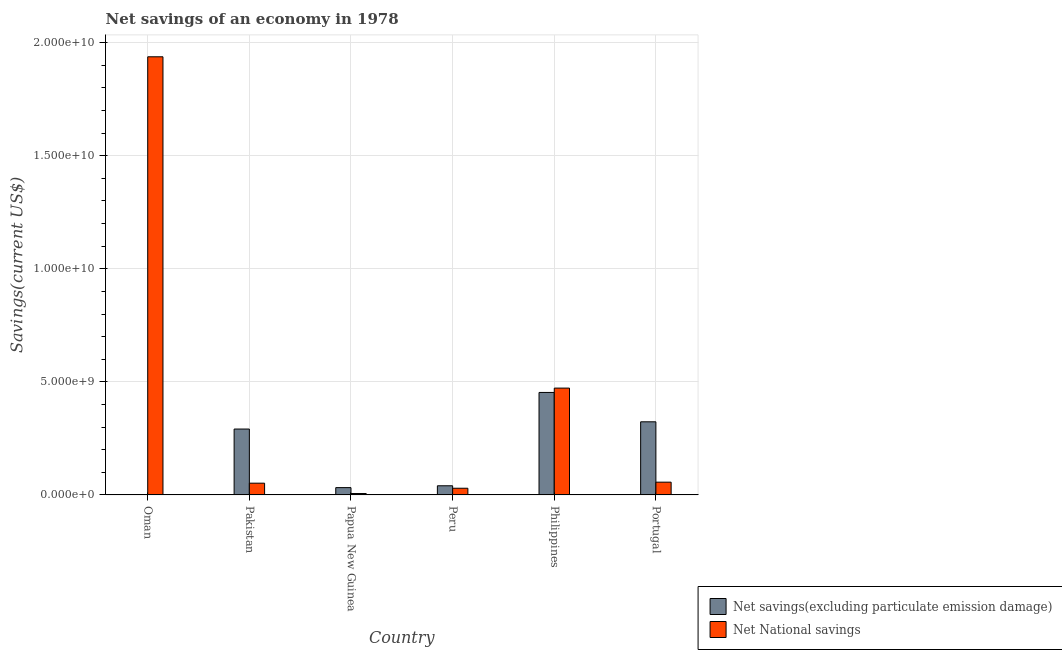Are the number of bars per tick equal to the number of legend labels?
Ensure brevity in your answer.  No. Are the number of bars on each tick of the X-axis equal?
Give a very brief answer. No. In how many cases, is the number of bars for a given country not equal to the number of legend labels?
Ensure brevity in your answer.  1. What is the net savings(excluding particulate emission damage) in Papua New Guinea?
Make the answer very short. 3.23e+08. Across all countries, what is the maximum net national savings?
Keep it short and to the point. 1.94e+1. In which country was the net savings(excluding particulate emission damage) maximum?
Make the answer very short. Philippines. What is the total net savings(excluding particulate emission damage) in the graph?
Keep it short and to the point. 1.14e+1. What is the difference between the net savings(excluding particulate emission damage) in Pakistan and that in Portugal?
Your answer should be compact. -3.20e+08. What is the difference between the net national savings in Peru and the net savings(excluding particulate emission damage) in Papua New Guinea?
Your answer should be compact. -2.77e+07. What is the average net savings(excluding particulate emission damage) per country?
Make the answer very short. 1.90e+09. What is the difference between the net national savings and net savings(excluding particulate emission damage) in Pakistan?
Give a very brief answer. -2.39e+09. In how many countries, is the net savings(excluding particulate emission damage) greater than 3000000000 US$?
Make the answer very short. 2. What is the ratio of the net savings(excluding particulate emission damage) in Pakistan to that in Peru?
Provide a succinct answer. 7.2. What is the difference between the highest and the second highest net national savings?
Keep it short and to the point. 1.47e+1. What is the difference between the highest and the lowest net national savings?
Your answer should be very brief. 1.93e+1. In how many countries, is the net national savings greater than the average net national savings taken over all countries?
Make the answer very short. 2. Is the sum of the net national savings in Oman and Pakistan greater than the maximum net savings(excluding particulate emission damage) across all countries?
Ensure brevity in your answer.  Yes. Are all the bars in the graph horizontal?
Ensure brevity in your answer.  No. How many countries are there in the graph?
Your response must be concise. 6. Are the values on the major ticks of Y-axis written in scientific E-notation?
Give a very brief answer. Yes. Does the graph contain grids?
Your response must be concise. Yes. Where does the legend appear in the graph?
Offer a terse response. Bottom right. What is the title of the graph?
Your answer should be compact. Net savings of an economy in 1978. What is the label or title of the X-axis?
Offer a very short reply. Country. What is the label or title of the Y-axis?
Ensure brevity in your answer.  Savings(current US$). What is the Savings(current US$) in Net savings(excluding particulate emission damage) in Oman?
Ensure brevity in your answer.  0. What is the Savings(current US$) in Net National savings in Oman?
Keep it short and to the point. 1.94e+1. What is the Savings(current US$) of Net savings(excluding particulate emission damage) in Pakistan?
Make the answer very short. 2.91e+09. What is the Savings(current US$) of Net National savings in Pakistan?
Provide a succinct answer. 5.20e+08. What is the Savings(current US$) in Net savings(excluding particulate emission damage) in Papua New Guinea?
Give a very brief answer. 3.23e+08. What is the Savings(current US$) of Net National savings in Papua New Guinea?
Provide a short and direct response. 6.22e+07. What is the Savings(current US$) in Net savings(excluding particulate emission damage) in Peru?
Your answer should be compact. 4.05e+08. What is the Savings(current US$) in Net National savings in Peru?
Keep it short and to the point. 2.96e+08. What is the Savings(current US$) in Net savings(excluding particulate emission damage) in Philippines?
Provide a short and direct response. 4.53e+09. What is the Savings(current US$) in Net National savings in Philippines?
Provide a succinct answer. 4.72e+09. What is the Savings(current US$) of Net savings(excluding particulate emission damage) in Portugal?
Ensure brevity in your answer.  3.23e+09. What is the Savings(current US$) of Net National savings in Portugal?
Give a very brief answer. 5.64e+08. Across all countries, what is the maximum Savings(current US$) in Net savings(excluding particulate emission damage)?
Offer a very short reply. 4.53e+09. Across all countries, what is the maximum Savings(current US$) of Net National savings?
Offer a terse response. 1.94e+1. Across all countries, what is the minimum Savings(current US$) of Net savings(excluding particulate emission damage)?
Offer a terse response. 0. Across all countries, what is the minimum Savings(current US$) in Net National savings?
Ensure brevity in your answer.  6.22e+07. What is the total Savings(current US$) of Net savings(excluding particulate emission damage) in the graph?
Ensure brevity in your answer.  1.14e+1. What is the total Savings(current US$) in Net National savings in the graph?
Provide a succinct answer. 2.55e+1. What is the difference between the Savings(current US$) of Net National savings in Oman and that in Pakistan?
Make the answer very short. 1.89e+1. What is the difference between the Savings(current US$) in Net National savings in Oman and that in Papua New Guinea?
Offer a very short reply. 1.93e+1. What is the difference between the Savings(current US$) of Net National savings in Oman and that in Peru?
Provide a succinct answer. 1.91e+1. What is the difference between the Savings(current US$) in Net National savings in Oman and that in Philippines?
Offer a terse response. 1.47e+1. What is the difference between the Savings(current US$) in Net National savings in Oman and that in Portugal?
Provide a succinct answer. 1.88e+1. What is the difference between the Savings(current US$) of Net savings(excluding particulate emission damage) in Pakistan and that in Papua New Guinea?
Offer a terse response. 2.59e+09. What is the difference between the Savings(current US$) of Net National savings in Pakistan and that in Papua New Guinea?
Your response must be concise. 4.58e+08. What is the difference between the Savings(current US$) of Net savings(excluding particulate emission damage) in Pakistan and that in Peru?
Make the answer very short. 2.51e+09. What is the difference between the Savings(current US$) in Net National savings in Pakistan and that in Peru?
Give a very brief answer. 2.24e+08. What is the difference between the Savings(current US$) of Net savings(excluding particulate emission damage) in Pakistan and that in Philippines?
Ensure brevity in your answer.  -1.62e+09. What is the difference between the Savings(current US$) in Net National savings in Pakistan and that in Philippines?
Your answer should be compact. -4.20e+09. What is the difference between the Savings(current US$) of Net savings(excluding particulate emission damage) in Pakistan and that in Portugal?
Make the answer very short. -3.20e+08. What is the difference between the Savings(current US$) in Net National savings in Pakistan and that in Portugal?
Keep it short and to the point. -4.46e+07. What is the difference between the Savings(current US$) of Net savings(excluding particulate emission damage) in Papua New Guinea and that in Peru?
Provide a short and direct response. -8.15e+07. What is the difference between the Savings(current US$) of Net National savings in Papua New Guinea and that in Peru?
Offer a terse response. -2.33e+08. What is the difference between the Savings(current US$) of Net savings(excluding particulate emission damage) in Papua New Guinea and that in Philippines?
Make the answer very short. -4.21e+09. What is the difference between the Savings(current US$) in Net National savings in Papua New Guinea and that in Philippines?
Offer a very short reply. -4.66e+09. What is the difference between the Savings(current US$) of Net savings(excluding particulate emission damage) in Papua New Guinea and that in Portugal?
Ensure brevity in your answer.  -2.91e+09. What is the difference between the Savings(current US$) in Net National savings in Papua New Guinea and that in Portugal?
Provide a succinct answer. -5.02e+08. What is the difference between the Savings(current US$) in Net savings(excluding particulate emission damage) in Peru and that in Philippines?
Your answer should be compact. -4.13e+09. What is the difference between the Savings(current US$) in Net National savings in Peru and that in Philippines?
Your answer should be very brief. -4.43e+09. What is the difference between the Savings(current US$) in Net savings(excluding particulate emission damage) in Peru and that in Portugal?
Offer a terse response. -2.83e+09. What is the difference between the Savings(current US$) of Net National savings in Peru and that in Portugal?
Keep it short and to the point. -2.69e+08. What is the difference between the Savings(current US$) in Net savings(excluding particulate emission damage) in Philippines and that in Portugal?
Provide a short and direct response. 1.30e+09. What is the difference between the Savings(current US$) in Net National savings in Philippines and that in Portugal?
Your response must be concise. 4.16e+09. What is the difference between the Savings(current US$) in Net savings(excluding particulate emission damage) in Pakistan and the Savings(current US$) in Net National savings in Papua New Guinea?
Provide a short and direct response. 2.85e+09. What is the difference between the Savings(current US$) of Net savings(excluding particulate emission damage) in Pakistan and the Savings(current US$) of Net National savings in Peru?
Your answer should be very brief. 2.62e+09. What is the difference between the Savings(current US$) of Net savings(excluding particulate emission damage) in Pakistan and the Savings(current US$) of Net National savings in Philippines?
Ensure brevity in your answer.  -1.81e+09. What is the difference between the Savings(current US$) of Net savings(excluding particulate emission damage) in Pakistan and the Savings(current US$) of Net National savings in Portugal?
Offer a very short reply. 2.35e+09. What is the difference between the Savings(current US$) in Net savings(excluding particulate emission damage) in Papua New Guinea and the Savings(current US$) in Net National savings in Peru?
Your response must be concise. 2.77e+07. What is the difference between the Savings(current US$) in Net savings(excluding particulate emission damage) in Papua New Guinea and the Savings(current US$) in Net National savings in Philippines?
Provide a short and direct response. -4.40e+09. What is the difference between the Savings(current US$) in Net savings(excluding particulate emission damage) in Papua New Guinea and the Savings(current US$) in Net National savings in Portugal?
Keep it short and to the point. -2.41e+08. What is the difference between the Savings(current US$) in Net savings(excluding particulate emission damage) in Peru and the Savings(current US$) in Net National savings in Philippines?
Ensure brevity in your answer.  -4.32e+09. What is the difference between the Savings(current US$) in Net savings(excluding particulate emission damage) in Peru and the Savings(current US$) in Net National savings in Portugal?
Provide a short and direct response. -1.60e+08. What is the difference between the Savings(current US$) in Net savings(excluding particulate emission damage) in Philippines and the Savings(current US$) in Net National savings in Portugal?
Provide a short and direct response. 3.97e+09. What is the average Savings(current US$) of Net savings(excluding particulate emission damage) per country?
Provide a short and direct response. 1.90e+09. What is the average Savings(current US$) of Net National savings per country?
Offer a terse response. 4.26e+09. What is the difference between the Savings(current US$) of Net savings(excluding particulate emission damage) and Savings(current US$) of Net National savings in Pakistan?
Offer a terse response. 2.39e+09. What is the difference between the Savings(current US$) in Net savings(excluding particulate emission damage) and Savings(current US$) in Net National savings in Papua New Guinea?
Your answer should be very brief. 2.61e+08. What is the difference between the Savings(current US$) in Net savings(excluding particulate emission damage) and Savings(current US$) in Net National savings in Peru?
Provide a succinct answer. 1.09e+08. What is the difference between the Savings(current US$) of Net savings(excluding particulate emission damage) and Savings(current US$) of Net National savings in Philippines?
Provide a short and direct response. -1.92e+08. What is the difference between the Savings(current US$) of Net savings(excluding particulate emission damage) and Savings(current US$) of Net National savings in Portugal?
Offer a terse response. 2.67e+09. What is the ratio of the Savings(current US$) of Net National savings in Oman to that in Pakistan?
Provide a succinct answer. 37.28. What is the ratio of the Savings(current US$) of Net National savings in Oman to that in Papua New Guinea?
Keep it short and to the point. 311.7. What is the ratio of the Savings(current US$) of Net National savings in Oman to that in Peru?
Provide a short and direct response. 65.55. What is the ratio of the Savings(current US$) in Net National savings in Oman to that in Philippines?
Make the answer very short. 4.1. What is the ratio of the Savings(current US$) of Net National savings in Oman to that in Portugal?
Provide a short and direct response. 34.33. What is the ratio of the Savings(current US$) of Net savings(excluding particulate emission damage) in Pakistan to that in Papua New Guinea?
Your response must be concise. 9.01. What is the ratio of the Savings(current US$) of Net National savings in Pakistan to that in Papua New Guinea?
Your response must be concise. 8.36. What is the ratio of the Savings(current US$) of Net savings(excluding particulate emission damage) in Pakistan to that in Peru?
Your response must be concise. 7.2. What is the ratio of the Savings(current US$) in Net National savings in Pakistan to that in Peru?
Your response must be concise. 1.76. What is the ratio of the Savings(current US$) of Net savings(excluding particulate emission damage) in Pakistan to that in Philippines?
Your response must be concise. 0.64. What is the ratio of the Savings(current US$) of Net National savings in Pakistan to that in Philippines?
Offer a terse response. 0.11. What is the ratio of the Savings(current US$) of Net savings(excluding particulate emission damage) in Pakistan to that in Portugal?
Provide a succinct answer. 0.9. What is the ratio of the Savings(current US$) in Net National savings in Pakistan to that in Portugal?
Your answer should be compact. 0.92. What is the ratio of the Savings(current US$) in Net savings(excluding particulate emission damage) in Papua New Guinea to that in Peru?
Offer a very short reply. 0.8. What is the ratio of the Savings(current US$) of Net National savings in Papua New Guinea to that in Peru?
Offer a very short reply. 0.21. What is the ratio of the Savings(current US$) in Net savings(excluding particulate emission damage) in Papua New Guinea to that in Philippines?
Provide a succinct answer. 0.07. What is the ratio of the Savings(current US$) in Net National savings in Papua New Guinea to that in Philippines?
Your answer should be very brief. 0.01. What is the ratio of the Savings(current US$) of Net savings(excluding particulate emission damage) in Papua New Guinea to that in Portugal?
Offer a very short reply. 0.1. What is the ratio of the Savings(current US$) of Net National savings in Papua New Guinea to that in Portugal?
Provide a succinct answer. 0.11. What is the ratio of the Savings(current US$) of Net savings(excluding particulate emission damage) in Peru to that in Philippines?
Ensure brevity in your answer.  0.09. What is the ratio of the Savings(current US$) of Net National savings in Peru to that in Philippines?
Ensure brevity in your answer.  0.06. What is the ratio of the Savings(current US$) in Net savings(excluding particulate emission damage) in Peru to that in Portugal?
Offer a terse response. 0.13. What is the ratio of the Savings(current US$) in Net National savings in Peru to that in Portugal?
Offer a terse response. 0.52. What is the ratio of the Savings(current US$) of Net savings(excluding particulate emission damage) in Philippines to that in Portugal?
Keep it short and to the point. 1.4. What is the ratio of the Savings(current US$) in Net National savings in Philippines to that in Portugal?
Your response must be concise. 8.37. What is the difference between the highest and the second highest Savings(current US$) in Net savings(excluding particulate emission damage)?
Offer a terse response. 1.30e+09. What is the difference between the highest and the second highest Savings(current US$) in Net National savings?
Keep it short and to the point. 1.47e+1. What is the difference between the highest and the lowest Savings(current US$) of Net savings(excluding particulate emission damage)?
Ensure brevity in your answer.  4.53e+09. What is the difference between the highest and the lowest Savings(current US$) of Net National savings?
Keep it short and to the point. 1.93e+1. 